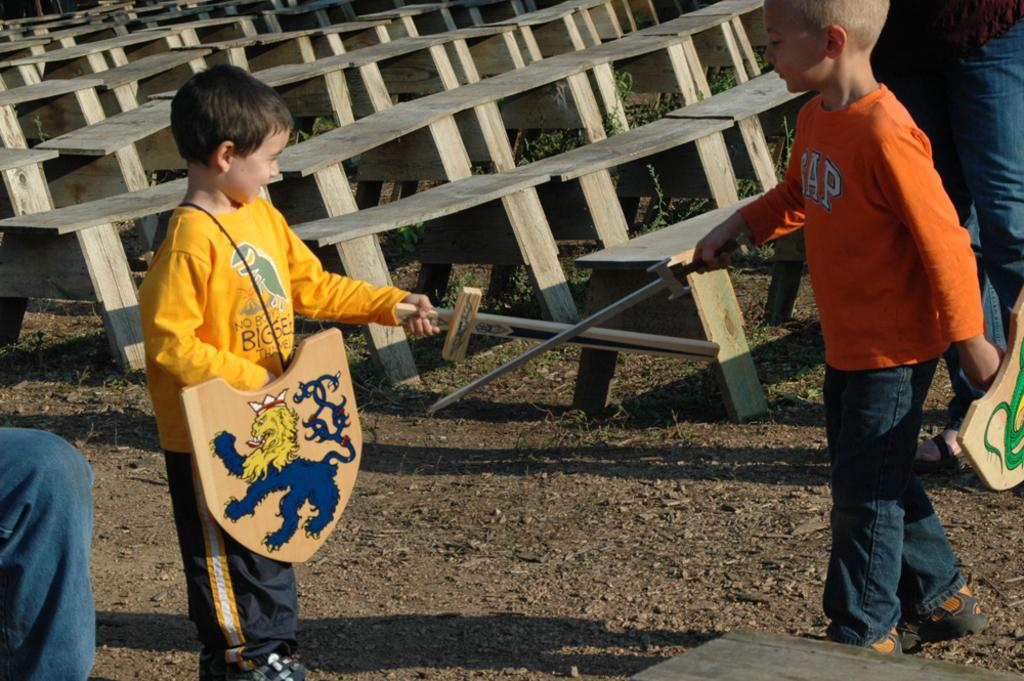How many boys are in the image? There are two boys in the image. What are the boys doing in the image? The boys are standing and holding swords and shields. What can be seen in the background of the image? There are benches and grass in the image. What part of the boys' bodies can be seen in the image? The legs of the boys are visible. What type of rice is being harvested in the image? There is no rice or harvesting activity present in the image. What material is the leather used for in the image? There is no leather or any leather-related objects present in the image. 